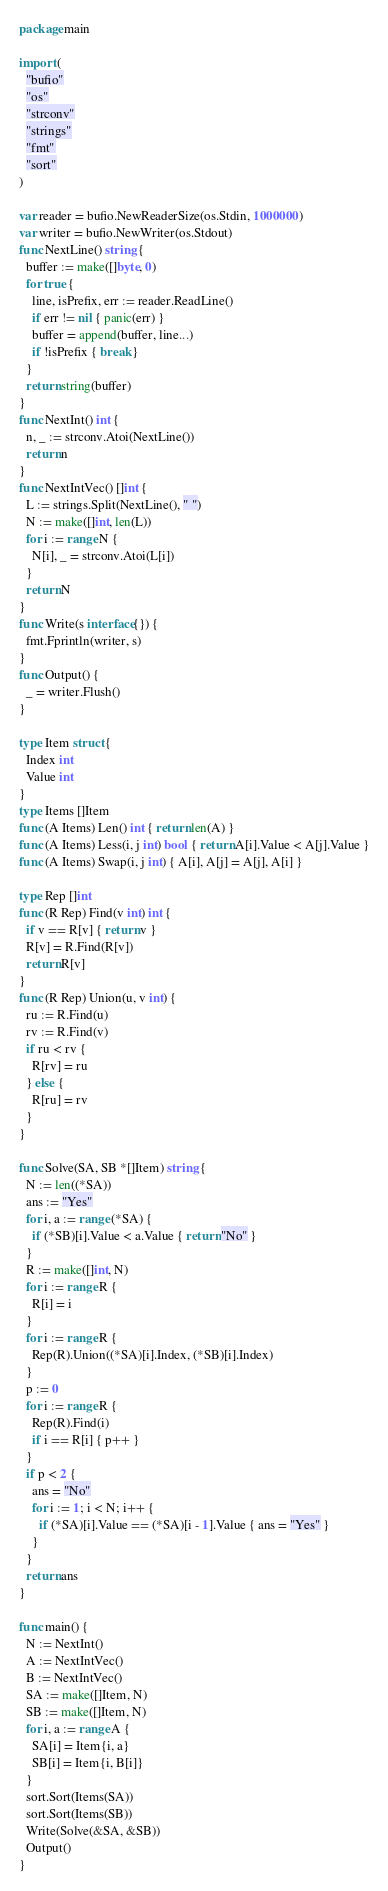<code> <loc_0><loc_0><loc_500><loc_500><_Go_>package main

import (
  "bufio"
  "os"
  "strconv"
  "strings"
  "fmt"
  "sort"
)

var reader = bufio.NewReaderSize(os.Stdin, 1000000)
var writer = bufio.NewWriter(os.Stdout)
func NextLine() string {
  buffer := make([]byte, 0)
  for true {
    line, isPrefix, err := reader.ReadLine()
    if err != nil { panic(err) }
    buffer = append(buffer, line...)
    if !isPrefix { break }
  }
  return string(buffer)
}
func NextInt() int {
  n, _ := strconv.Atoi(NextLine())
  return n
}
func NextIntVec() []int {
  L := strings.Split(NextLine(), " ")
  N := make([]int, len(L))
  for i := range N {
    N[i], _ = strconv.Atoi(L[i])
  }
  return N
}
func Write(s interface{}) {
  fmt.Fprintln(writer, s)
}
func Output() {
  _ = writer.Flush()
}

type Item struct {
  Index int
  Value int
}
type Items []Item
func (A Items) Len() int { return len(A) }
func (A Items) Less(i, j int) bool { return A[i].Value < A[j].Value }
func (A Items) Swap(i, j int) { A[i], A[j] = A[j], A[i] }

type Rep []int
func (R Rep) Find(v int) int {
  if v == R[v] { return v }
  R[v] = R.Find(R[v])
  return R[v]
}
func (R Rep) Union(u, v int) {
  ru := R.Find(u)
  rv := R.Find(v)
  if ru < rv {
    R[rv] = ru
  } else {
    R[ru] = rv
  }
}

func Solve(SA, SB *[]Item) string {
  N := len((*SA))
  ans := "Yes"
  for i, a := range (*SA) {
    if (*SB)[i].Value < a.Value { return "No" }
  }
  R := make([]int, N)
  for i := range R {
    R[i] = i
  }
  for i := range R {
    Rep(R).Union((*SA)[i].Index, (*SB)[i].Index)
  }
  p := 0
  for i := range R {
    Rep(R).Find(i)
    if i == R[i] { p++ }
  }
  if p < 2 {
    ans = "No"
    for i := 1; i < N; i++ {
      if (*SA)[i].Value == (*SA)[i - 1].Value { ans = "Yes" }
    }
  }
  return ans
}

func main() {
  N := NextInt()
  A := NextIntVec()
  B := NextIntVec()
  SA := make([]Item, N)
  SB := make([]Item, N)
  for i, a := range A {
    SA[i] = Item{i, a}
    SB[i] = Item{i, B[i]}
  }
  sort.Sort(Items(SA))
  sort.Sort(Items(SB))
  Write(Solve(&SA, &SB))
  Output()
}</code> 